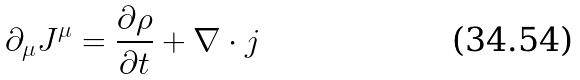Convert formula to latex. <formula><loc_0><loc_0><loc_500><loc_500>\partial _ { \mu } J ^ { \mu } = \frac { \partial \rho } { \partial t } + \nabla \cdot j</formula> 